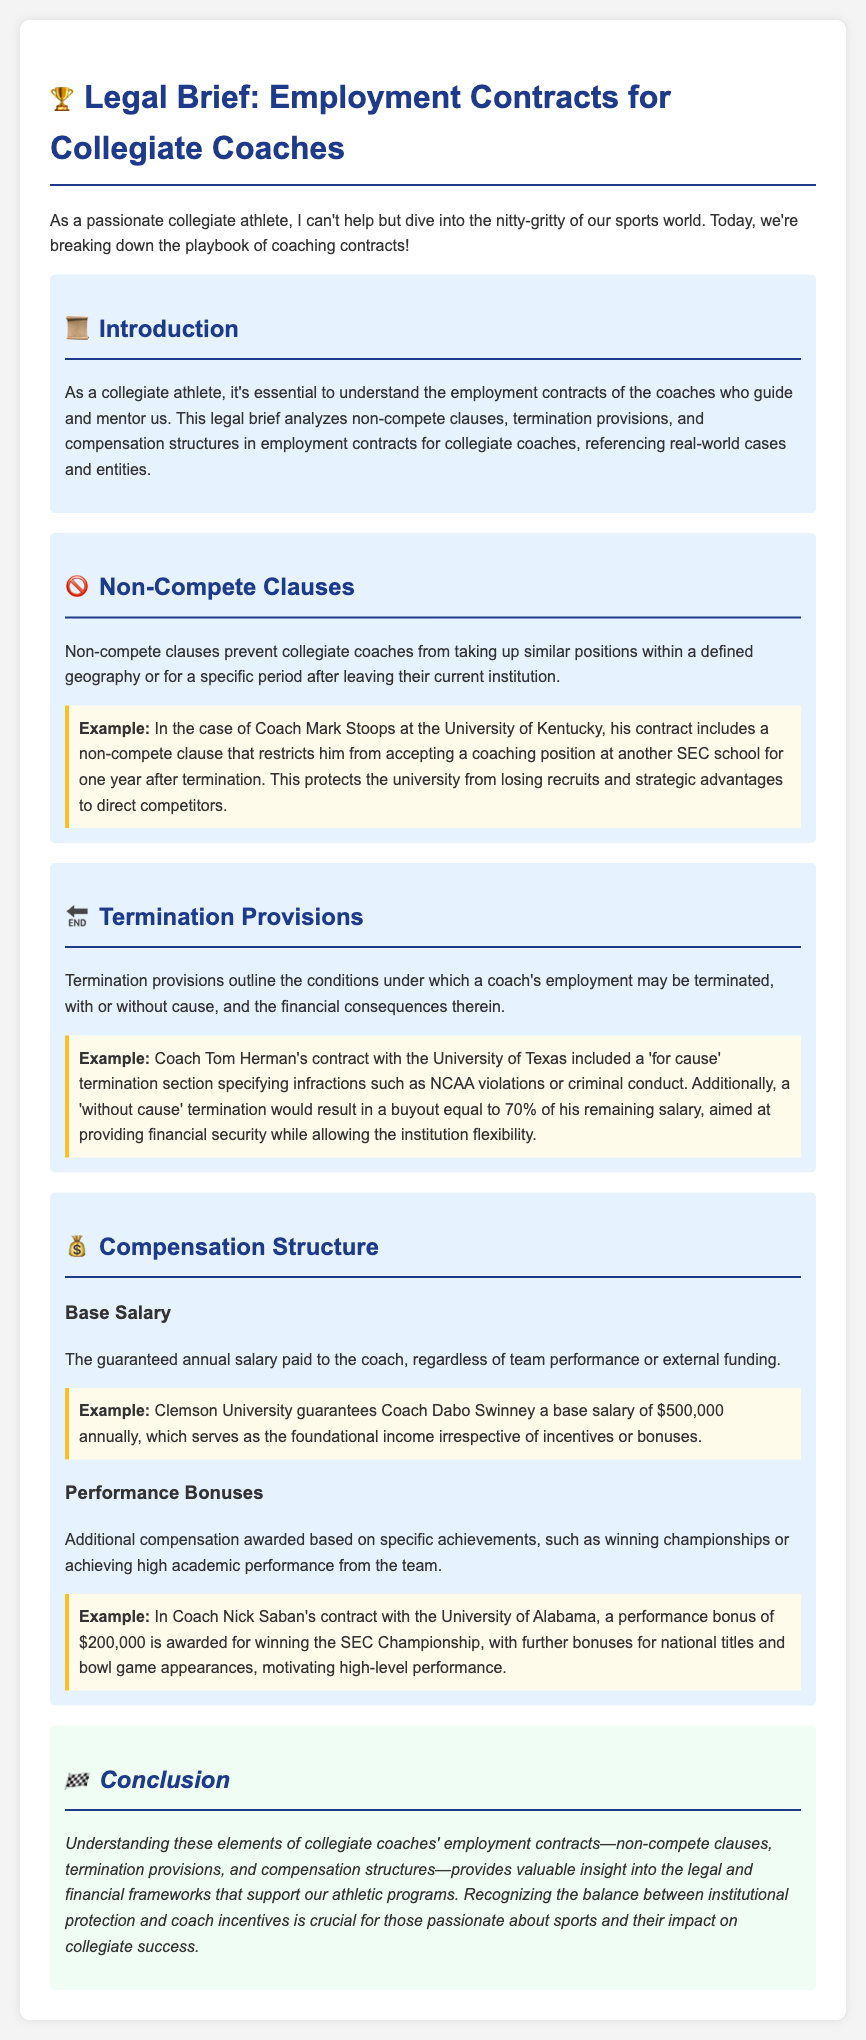What is the main topic of the legal brief? The legal brief analyzes non-compete clauses, termination provisions, and compensation structures in employment contracts for collegiate coaches.
Answer: Employment contracts for collegiate coaches What is an example of a non-compete clause mentioned in the document? The document references Coach Mark Stoops at the University of Kentucky, whose contract restricts him from coaching at another SEC school for one year after termination.
Answer: SEC school for one year What percentage of the remaining salary is provided as a buyout for 'without cause' termination? The document explains that a 'without cause' termination results in a buyout equal to 70% of the remaining salary.
Answer: 70% What is Coach Dabo Swinney's guaranteed annual base salary? The brief states that Clemson University guarantees Coach Dabo Swinney a base salary of $500,000 annually.
Answer: $500,000 What type of bonuses are included in the compensation structure? The document specifies performance bonuses awarded based on specific achievements, such as winning championships or academic performance.
Answer: Performance bonuses What is the protection purpose of non-compete clauses in coaching contracts? Non-compete clauses are intended to prevent collegiate coaches from taking similar positions within a defined geography or for a specific period after leaving their current institution.
Answer: Protects university What specific criterion can lead to 'for cause' termination in Coach Tom Herman's contract? The document notes that infractions such as NCAA violations or criminal conduct can lead to 'for cause' termination.
Answer: NCAA violations How much is the performance bonus for winning the SEC Championship according to Coach Nick Saban's contract? The document describes that a performance bonus of $200,000 is awarded for winning the SEC Championship.
Answer: $200,000 